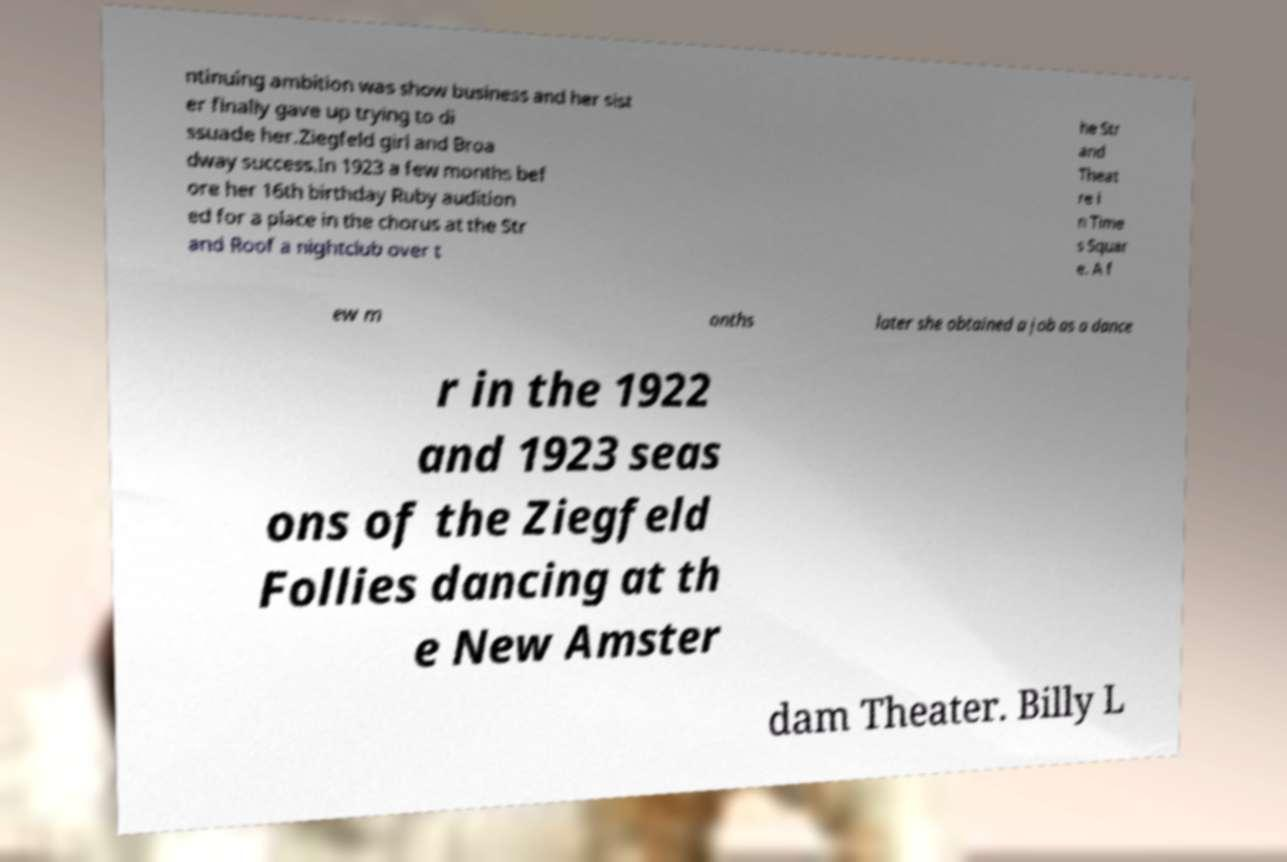Can you accurately transcribe the text from the provided image for me? ntinuing ambition was show business and her sist er finally gave up trying to di ssuade her.Ziegfeld girl and Broa dway success.In 1923 a few months bef ore her 16th birthday Ruby audition ed for a place in the chorus at the Str and Roof a nightclub over t he Str and Theat re i n Time s Squar e. A f ew m onths later she obtained a job as a dance r in the 1922 and 1923 seas ons of the Ziegfeld Follies dancing at th e New Amster dam Theater. Billy L 